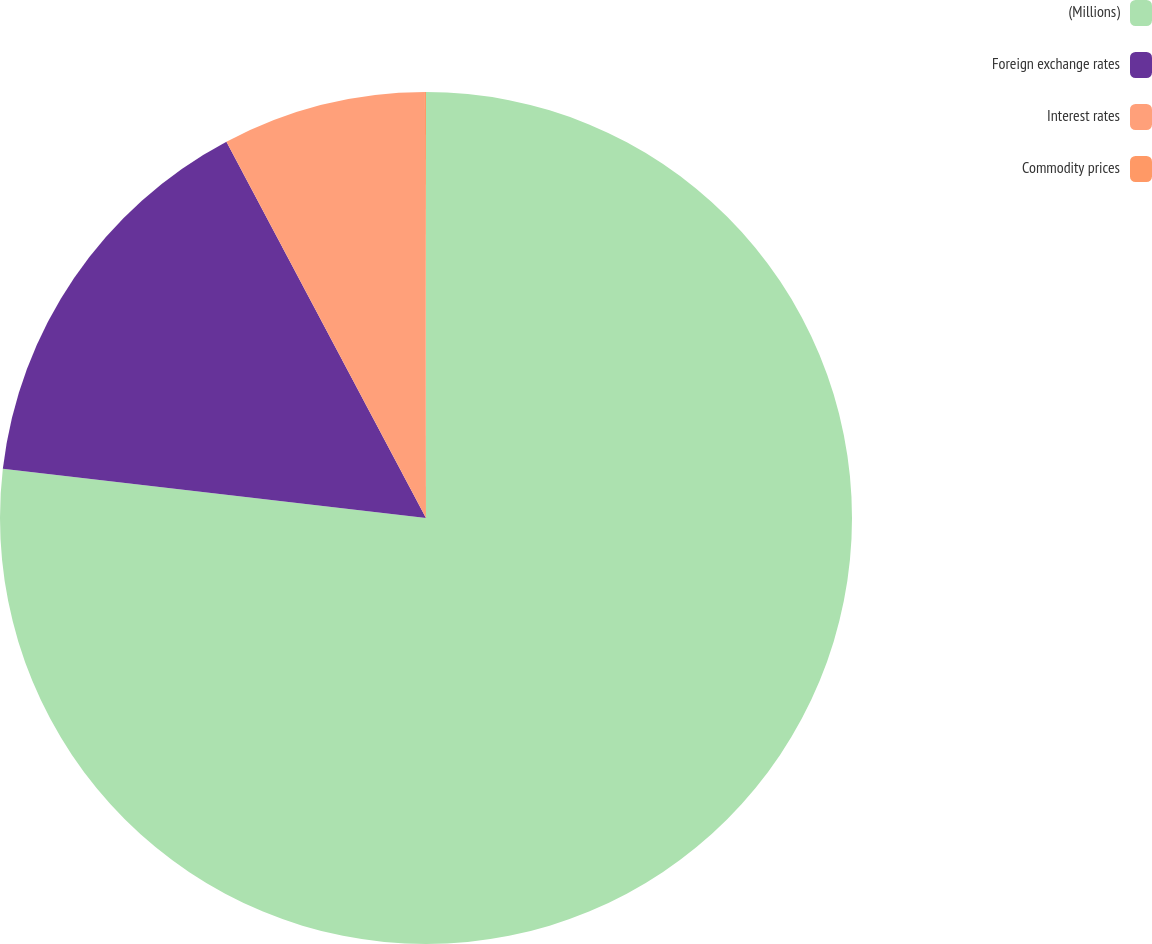<chart> <loc_0><loc_0><loc_500><loc_500><pie_chart><fcel>(Millions)<fcel>Foreign exchange rates<fcel>Interest rates<fcel>Commodity prices<nl><fcel>76.84%<fcel>15.4%<fcel>7.72%<fcel>0.04%<nl></chart> 